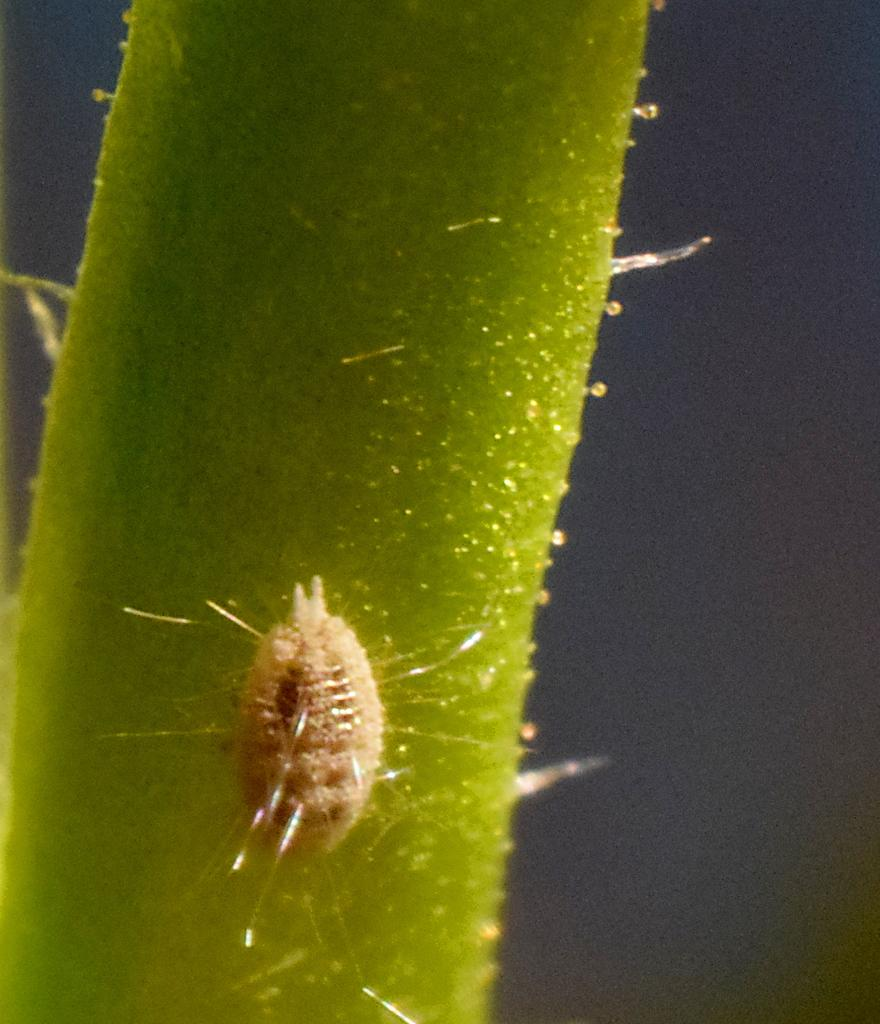What is the color of the stem in the image? The stem in the image is green. What is present on the stem? There is an insect on the stem. What color is the background of the image? The background of the image is black. What book is the man reading in the image? There is no man or book present in the image; it features a green stem with an insect on it against a black background. 